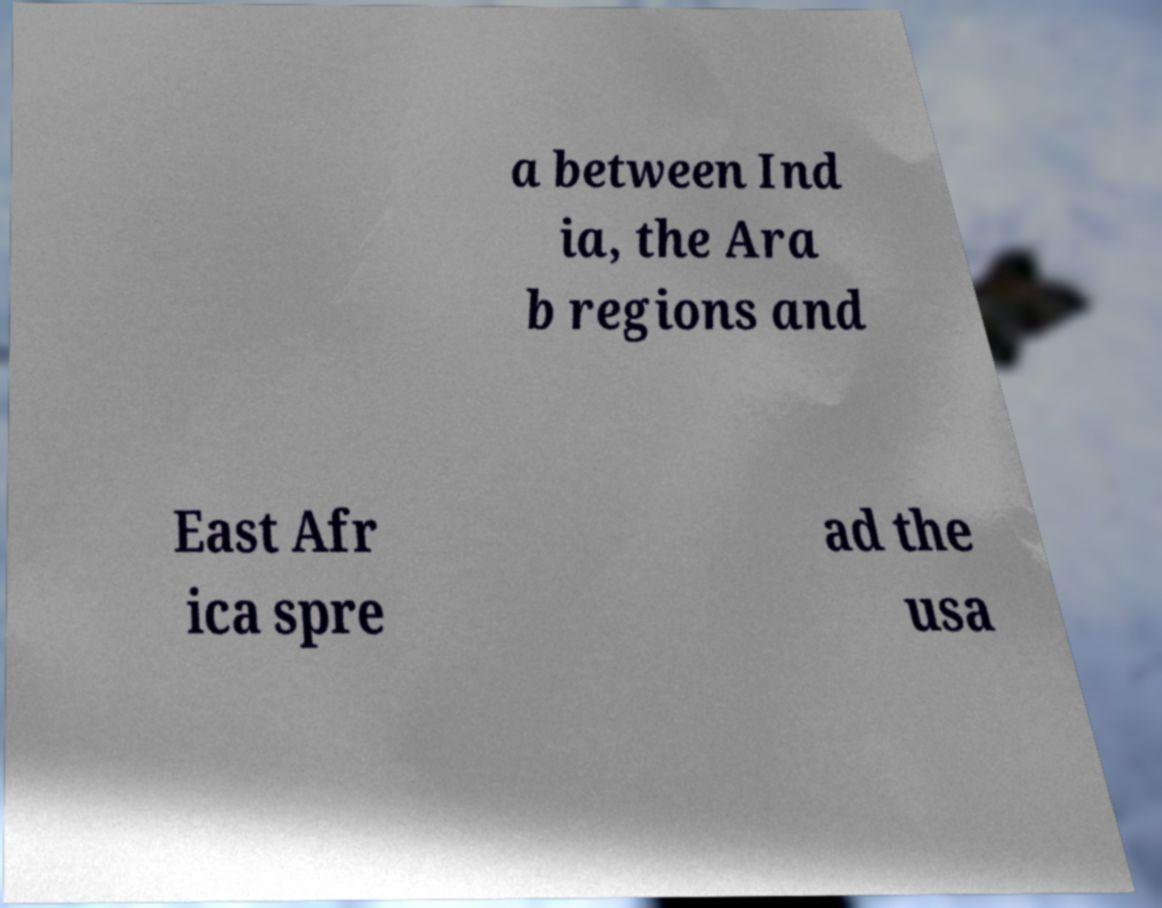There's text embedded in this image that I need extracted. Can you transcribe it verbatim? a between Ind ia, the Ara b regions and East Afr ica spre ad the usa 